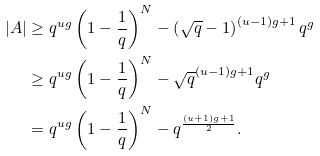Convert formula to latex. <formula><loc_0><loc_0><loc_500><loc_500>| A | & \geq q ^ { u g } \left ( 1 - \frac { 1 } { q } \right ) ^ { N } - \left ( \sqrt { q } - 1 \right ) ^ { ( u - 1 ) g + 1 } q ^ { g } \\ & \geq q ^ { u g } \left ( 1 - \frac { 1 } { q } \right ) ^ { N } - \sqrt { q } ^ { ( u - 1 ) g + 1 } q ^ { g } \\ & = q ^ { u g } \left ( 1 - \frac { 1 } { q } \right ) ^ { N } - q ^ { \frac { ( u + 1 ) g + 1 } { 2 } } .</formula> 